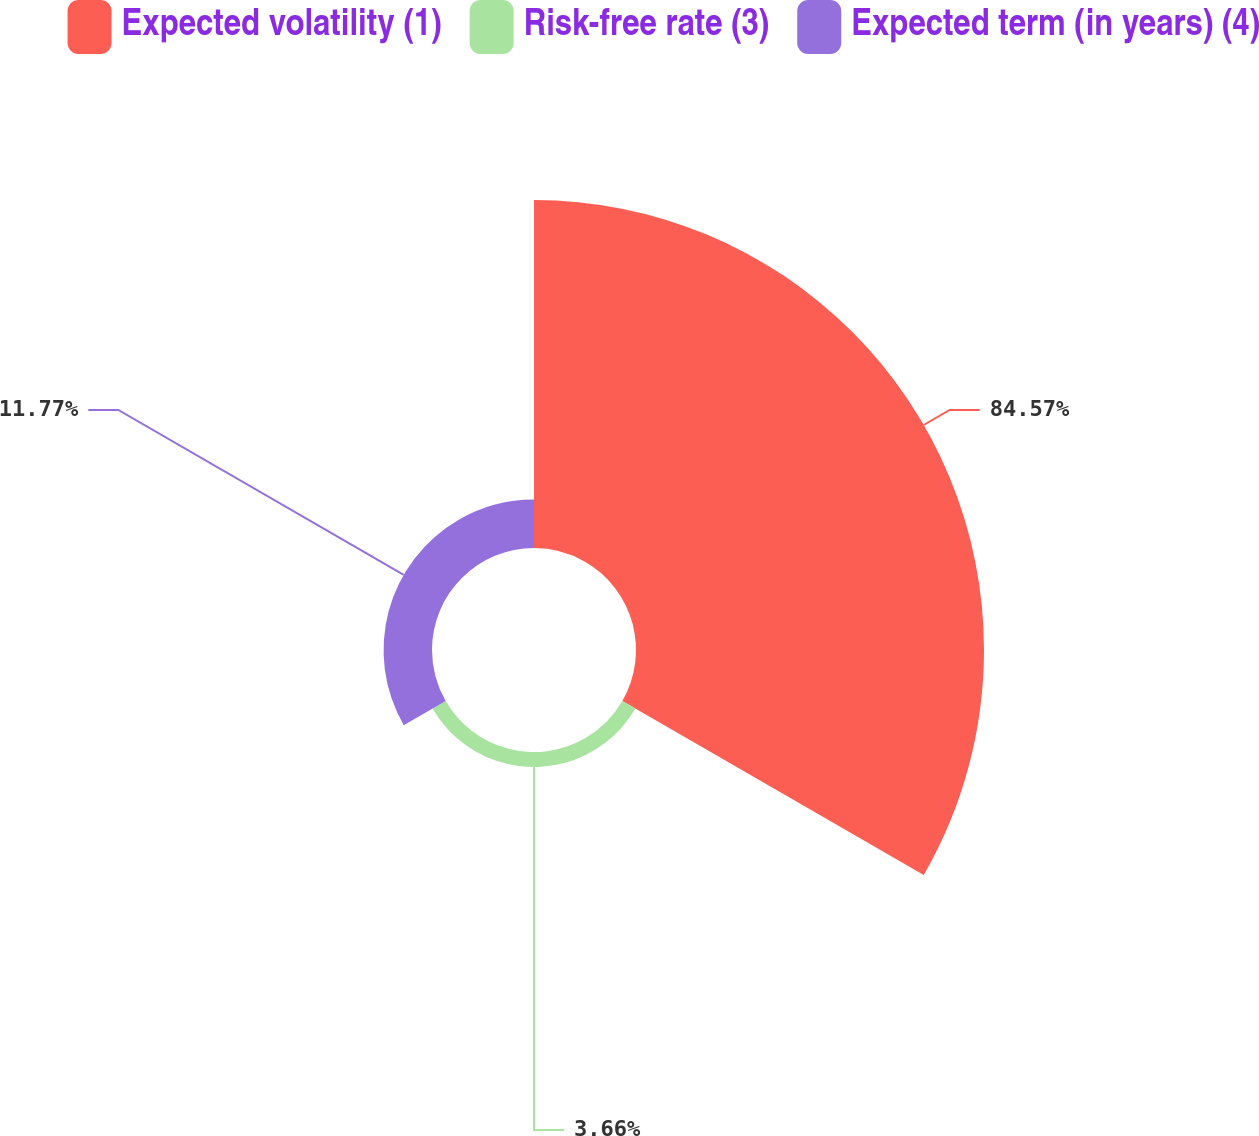Convert chart to OTSL. <chart><loc_0><loc_0><loc_500><loc_500><pie_chart><fcel>Expected volatility (1)<fcel>Risk-free rate (3)<fcel>Expected term (in years) (4)<nl><fcel>84.57%<fcel>3.66%<fcel>11.77%<nl></chart> 